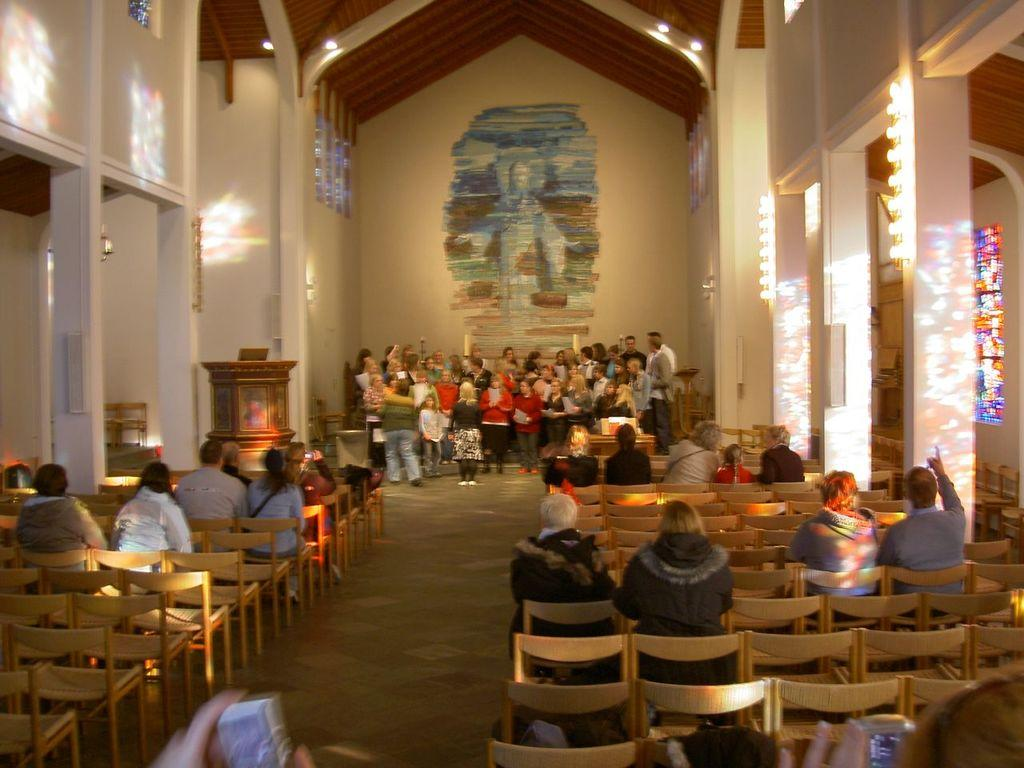What type of furniture is present in the room? There are chairs in the room. How are the chairs being used in the room? Some people are seated on the chairs. What is the position of the people who are not seated? Many people are standing at the back. What architectural features are present on either side of the chairs? There are pillars on either side of the chairs. What is providing illumination in the room? There are lights in the room. What type of trip are the people planning to take in the image? There is no indication of a trip or any travel plans in the image. How many women are present in the image? The provided facts do not specify the gender of the people in the image, so it cannot be determined how many women are present. 